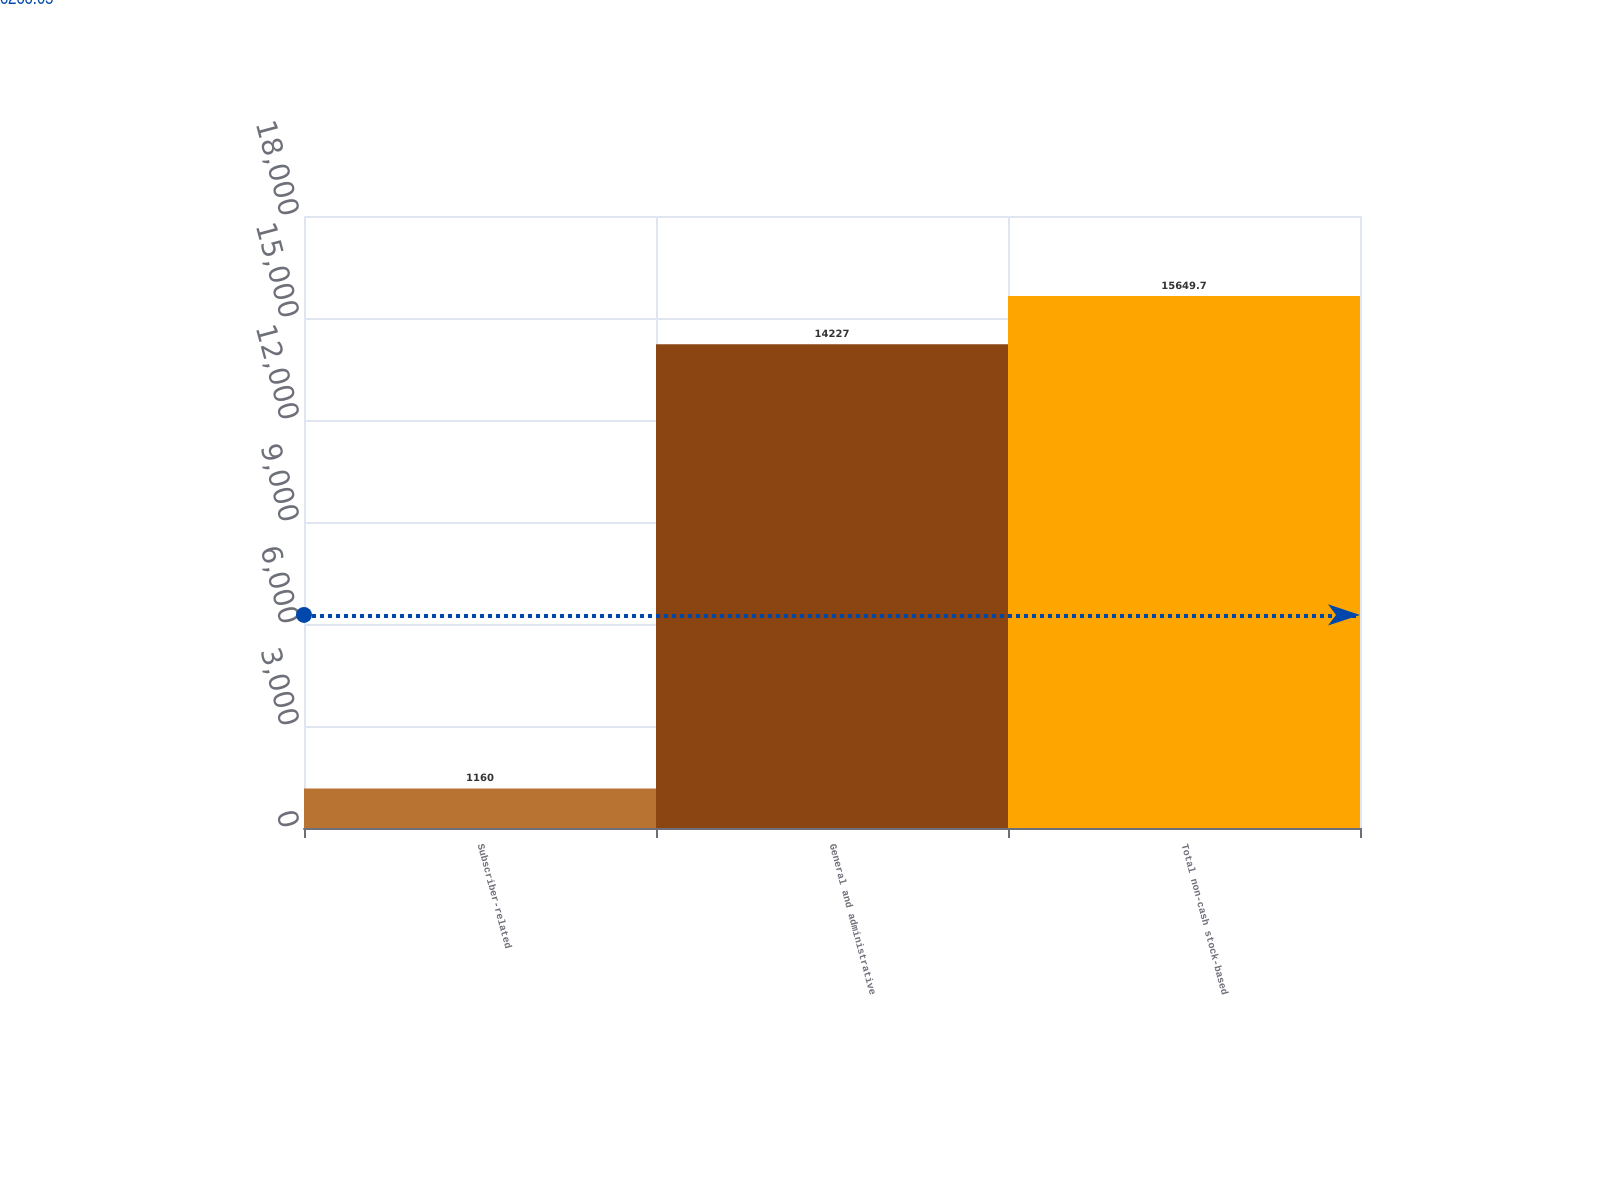Convert chart. <chart><loc_0><loc_0><loc_500><loc_500><bar_chart><fcel>Subscriber-related<fcel>General and administrative<fcel>Total non-cash stock-based<nl><fcel>1160<fcel>14227<fcel>15649.7<nl></chart> 